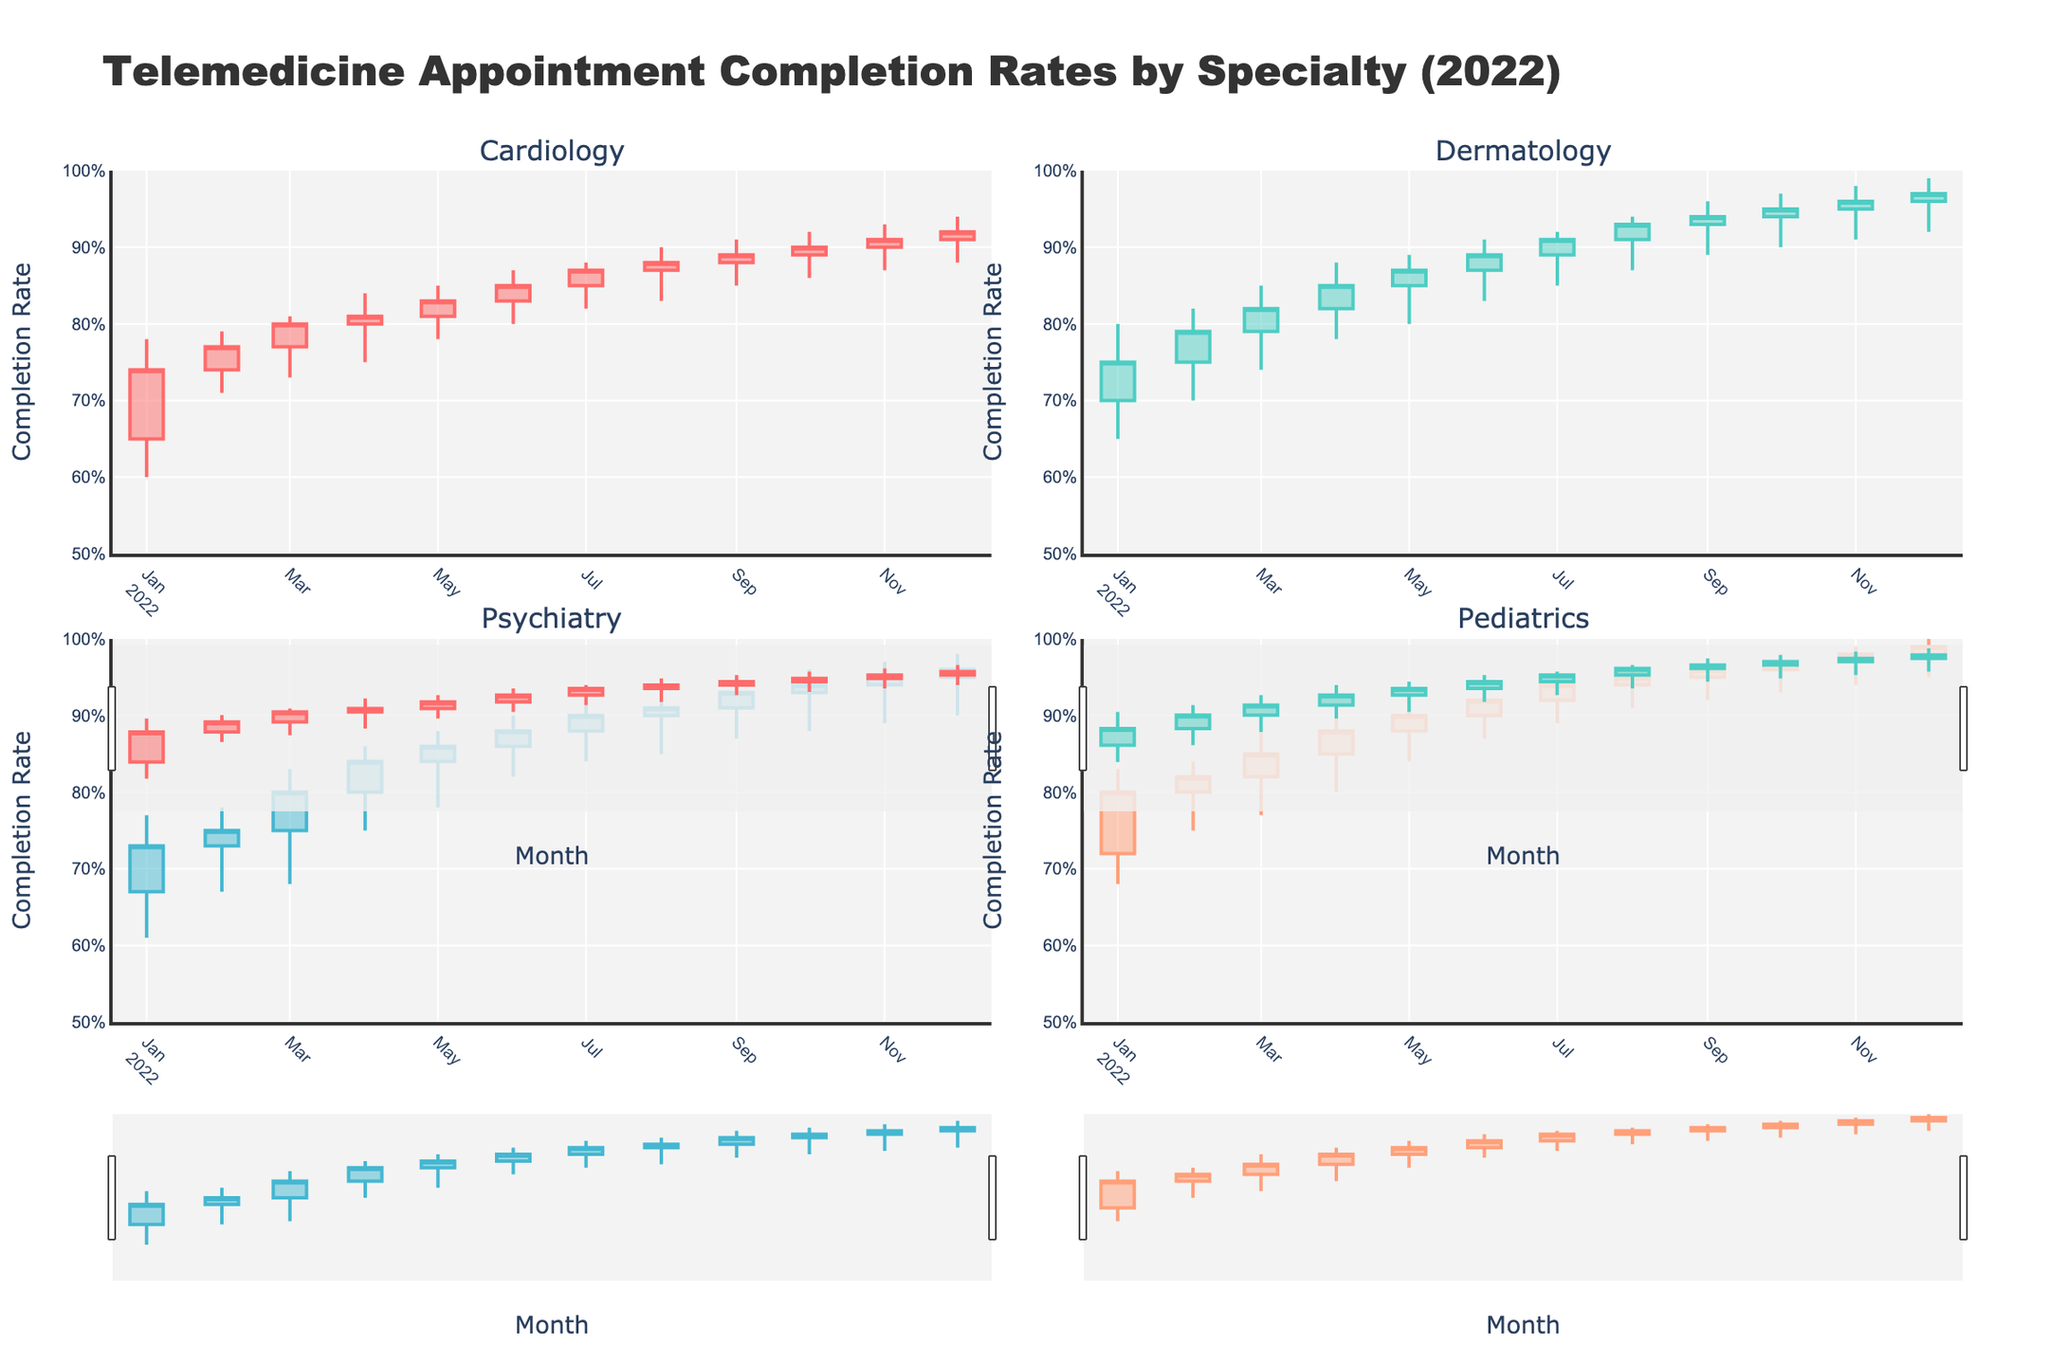What does the title of the candlestick plot indicate? The title "Telemedicine Appointment Completion Rates by Specialty (2022)" informs us that the figure displays the completion rates of telemedicine appointments, categorized by medical specialties over the year 2022.
Answer: Telemedicine Appointment Completion Rates by Specialty (2022) What months are shown on the x-axis? The x-axis displays the months from January 2022 to December 2022. Each candlestick represents data for a specific month within this timeframe.
Answer: January 2022 to December 2022 Which specialty had the highest closing completion rate in December 2022? To find the highest closing completion rate for December 2022, we look at the closing values of each specialty's candlestick for that month. Pediatrics had the highest closing rate of 0.99.
Answer: Pediatrics What is the primary color used to indicate increasing candlesticks for Cardiology? By examining the plot's color scheme, the primary color used for increasing candlesticks in Cardiology is identified as one of the standard shades represented, which is consistent across specialty plots.
Answer: A specific shade distinct from others (natural description without coding color, such as "red" or "blue") How did the Dermatology completion rates change from January to December 2022? We analyze the Dermatology candlestick plot, noting the “open” and “close” values for January and December 2022. The rate increased from 0.75 in January to 0.97 in December, indicating an overall upward trend.
Answer: Increased from 0.75 to 0.97 Which specialty had the lowest opening rate and in which month did it occur? To determine this, we scan each plot and identify the lowest “open” value. Psychiatry in January 2022 had the lowest opening rate of 0.67.
Answer: Psychiatry in January 2022 Compare the variability in completion rates for Pediatrics and Cardiology in June 2022. Which showed more variability? Variability is indicated by the difference between the high and low values of the candlestick. For Pediatrics, the difference was 0.94 - 0.87 = 0.07. For Cardiology, the difference was 0.87 - 0.80 = 0.07. Both specialties showed the same variability.
Answer: Same variability What was the trend for Psychiatry completion rates throughout the year? By observing Psychiatry’s monthly candlesticks, we notice an overall increasing trend in both the open and close values, indicating improving completion rates throughout 2022.
Answer: Increasing trend Did any specialty experience a decrease in completion rates at any point during 2022? A decreasing rate would be indicated by a candlestick where the close value is lower than the open. For example, Cardiology had a decrease from 0.83 to 0.81 in May.
Answer: Yes, Cardiology in May Between which two consecutive months did Cardiology see the highest increase in completion rates? We look for the month-to-month differences in Cardiology's close values. The highest increase was between January (0.74) and February (0.77), a rise of 0.03.
Answer: January to February 